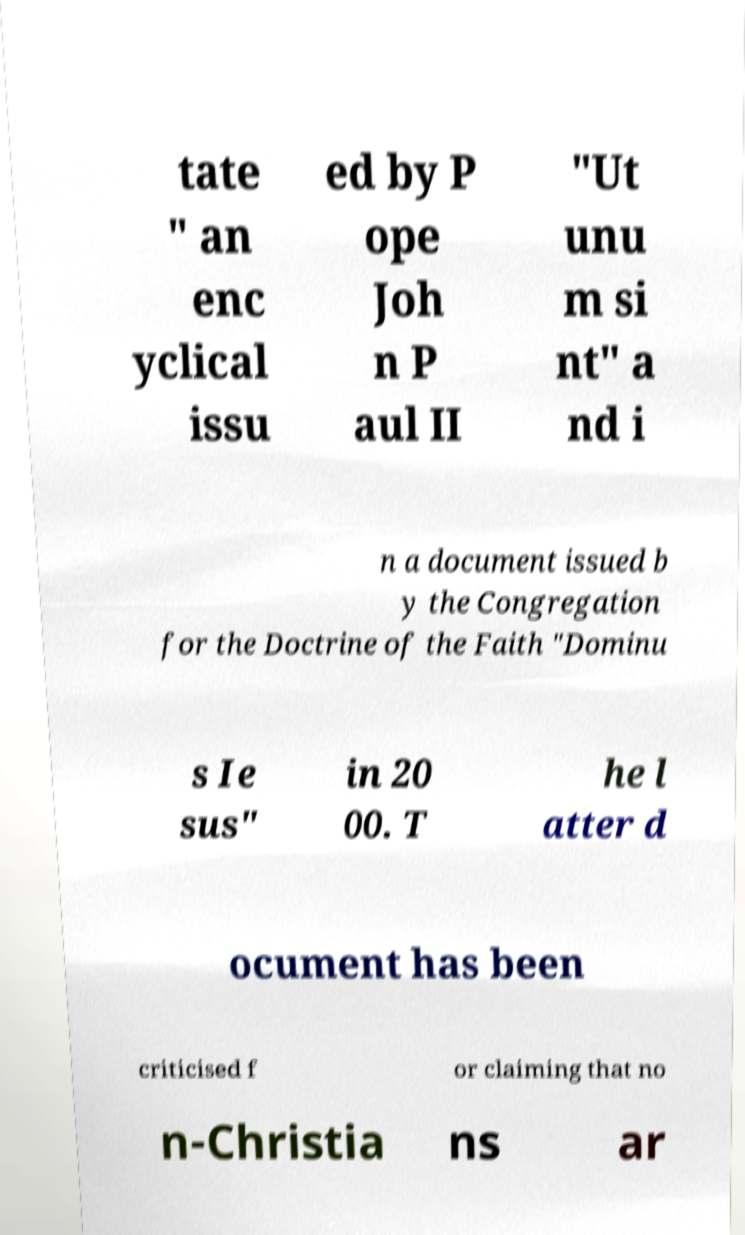Please read and relay the text visible in this image. What does it say? tate " an enc yclical issu ed by P ope Joh n P aul II "Ut unu m si nt" a nd i n a document issued b y the Congregation for the Doctrine of the Faith "Dominu s Ie sus" in 20 00. T he l atter d ocument has been criticised f or claiming that no n-Christia ns ar 